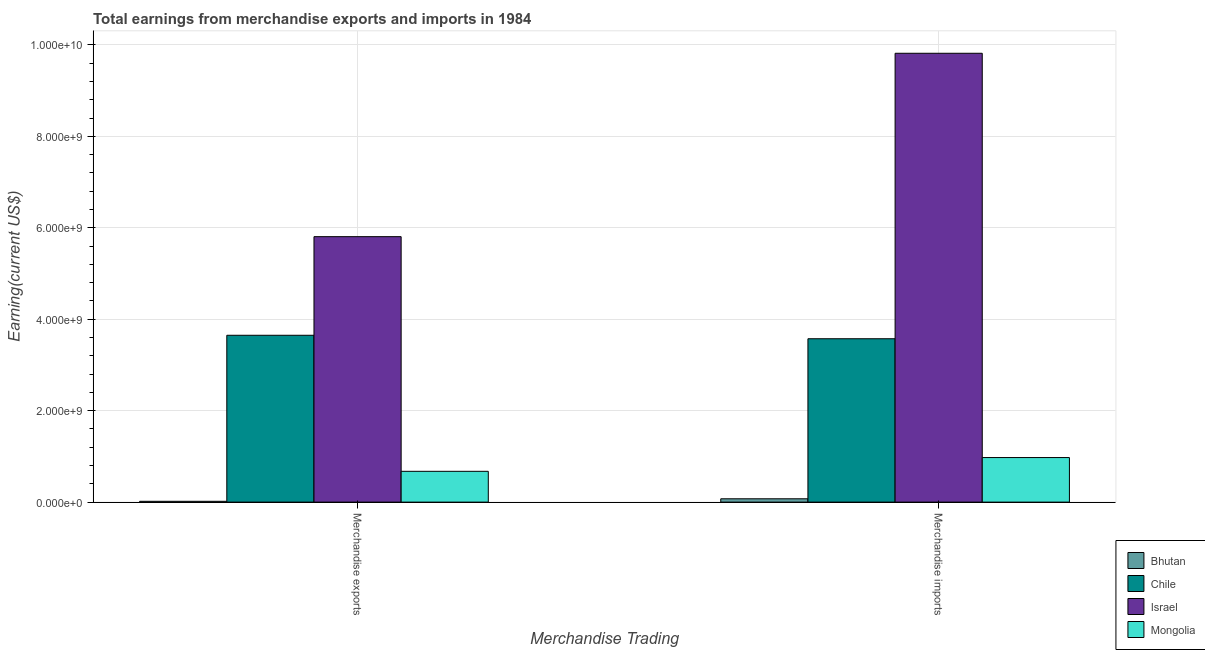How many groups of bars are there?
Offer a terse response. 2. Are the number of bars per tick equal to the number of legend labels?
Make the answer very short. Yes. Are the number of bars on each tick of the X-axis equal?
Offer a terse response. Yes. How many bars are there on the 2nd tick from the right?
Your answer should be compact. 4. What is the label of the 1st group of bars from the left?
Make the answer very short. Merchandise exports. What is the earnings from merchandise exports in Bhutan?
Provide a short and direct response. 1.80e+07. Across all countries, what is the maximum earnings from merchandise imports?
Your answer should be compact. 9.82e+09. Across all countries, what is the minimum earnings from merchandise exports?
Make the answer very short. 1.80e+07. In which country was the earnings from merchandise imports minimum?
Give a very brief answer. Bhutan. What is the total earnings from merchandise imports in the graph?
Give a very brief answer. 1.44e+1. What is the difference between the earnings from merchandise imports in Mongolia and that in Chile?
Provide a succinct answer. -2.60e+09. What is the difference between the earnings from merchandise imports in Chile and the earnings from merchandise exports in Israel?
Make the answer very short. -2.23e+09. What is the average earnings from merchandise imports per country?
Give a very brief answer. 3.61e+09. What is the difference between the earnings from merchandise imports and earnings from merchandise exports in Mongolia?
Ensure brevity in your answer.  3.01e+08. What is the ratio of the earnings from merchandise exports in Bhutan to that in Israel?
Your answer should be compact. 0. What does the 2nd bar from the left in Merchandise exports represents?
Offer a terse response. Chile. What does the 4th bar from the right in Merchandise exports represents?
Ensure brevity in your answer.  Bhutan. How many countries are there in the graph?
Provide a succinct answer. 4. What is the difference between two consecutive major ticks on the Y-axis?
Give a very brief answer. 2.00e+09. Does the graph contain any zero values?
Your answer should be very brief. No. Where does the legend appear in the graph?
Provide a short and direct response. Bottom right. What is the title of the graph?
Offer a very short reply. Total earnings from merchandise exports and imports in 1984. Does "Samoa" appear as one of the legend labels in the graph?
Ensure brevity in your answer.  No. What is the label or title of the X-axis?
Offer a very short reply. Merchandise Trading. What is the label or title of the Y-axis?
Provide a succinct answer. Earning(current US$). What is the Earning(current US$) in Bhutan in Merchandise exports?
Your answer should be compact. 1.80e+07. What is the Earning(current US$) of Chile in Merchandise exports?
Your answer should be compact. 3.65e+09. What is the Earning(current US$) in Israel in Merchandise exports?
Ensure brevity in your answer.  5.81e+09. What is the Earning(current US$) in Mongolia in Merchandise exports?
Provide a succinct answer. 6.74e+08. What is the Earning(current US$) of Bhutan in Merchandise imports?
Ensure brevity in your answer.  7.30e+07. What is the Earning(current US$) of Chile in Merchandise imports?
Make the answer very short. 3.57e+09. What is the Earning(current US$) in Israel in Merchandise imports?
Your answer should be compact. 9.82e+09. What is the Earning(current US$) in Mongolia in Merchandise imports?
Provide a short and direct response. 9.75e+08. Across all Merchandise Trading, what is the maximum Earning(current US$) of Bhutan?
Your response must be concise. 7.30e+07. Across all Merchandise Trading, what is the maximum Earning(current US$) of Chile?
Provide a succinct answer. 3.65e+09. Across all Merchandise Trading, what is the maximum Earning(current US$) of Israel?
Give a very brief answer. 9.82e+09. Across all Merchandise Trading, what is the maximum Earning(current US$) of Mongolia?
Ensure brevity in your answer.  9.75e+08. Across all Merchandise Trading, what is the minimum Earning(current US$) in Bhutan?
Ensure brevity in your answer.  1.80e+07. Across all Merchandise Trading, what is the minimum Earning(current US$) in Chile?
Offer a terse response. 3.57e+09. Across all Merchandise Trading, what is the minimum Earning(current US$) of Israel?
Provide a succinct answer. 5.81e+09. Across all Merchandise Trading, what is the minimum Earning(current US$) in Mongolia?
Ensure brevity in your answer.  6.74e+08. What is the total Earning(current US$) of Bhutan in the graph?
Offer a very short reply. 9.10e+07. What is the total Earning(current US$) of Chile in the graph?
Keep it short and to the point. 7.22e+09. What is the total Earning(current US$) of Israel in the graph?
Keep it short and to the point. 1.56e+1. What is the total Earning(current US$) of Mongolia in the graph?
Your response must be concise. 1.65e+09. What is the difference between the Earning(current US$) of Bhutan in Merchandise exports and that in Merchandise imports?
Make the answer very short. -5.50e+07. What is the difference between the Earning(current US$) in Chile in Merchandise exports and that in Merchandise imports?
Offer a terse response. 7.60e+07. What is the difference between the Earning(current US$) in Israel in Merchandise exports and that in Merchandise imports?
Offer a very short reply. -4.01e+09. What is the difference between the Earning(current US$) in Mongolia in Merchandise exports and that in Merchandise imports?
Your answer should be compact. -3.01e+08. What is the difference between the Earning(current US$) in Bhutan in Merchandise exports and the Earning(current US$) in Chile in Merchandise imports?
Your answer should be very brief. -3.56e+09. What is the difference between the Earning(current US$) in Bhutan in Merchandise exports and the Earning(current US$) in Israel in Merchandise imports?
Provide a short and direct response. -9.80e+09. What is the difference between the Earning(current US$) in Bhutan in Merchandise exports and the Earning(current US$) in Mongolia in Merchandise imports?
Provide a short and direct response. -9.57e+08. What is the difference between the Earning(current US$) of Chile in Merchandise exports and the Earning(current US$) of Israel in Merchandise imports?
Give a very brief answer. -6.17e+09. What is the difference between the Earning(current US$) of Chile in Merchandise exports and the Earning(current US$) of Mongolia in Merchandise imports?
Provide a short and direct response. 2.68e+09. What is the difference between the Earning(current US$) of Israel in Merchandise exports and the Earning(current US$) of Mongolia in Merchandise imports?
Give a very brief answer. 4.83e+09. What is the average Earning(current US$) of Bhutan per Merchandise Trading?
Provide a succinct answer. 4.55e+07. What is the average Earning(current US$) in Chile per Merchandise Trading?
Offer a terse response. 3.61e+09. What is the average Earning(current US$) in Israel per Merchandise Trading?
Your answer should be very brief. 7.81e+09. What is the average Earning(current US$) in Mongolia per Merchandise Trading?
Your answer should be very brief. 8.24e+08. What is the difference between the Earning(current US$) in Bhutan and Earning(current US$) in Chile in Merchandise exports?
Offer a very short reply. -3.63e+09. What is the difference between the Earning(current US$) of Bhutan and Earning(current US$) of Israel in Merchandise exports?
Provide a succinct answer. -5.79e+09. What is the difference between the Earning(current US$) in Bhutan and Earning(current US$) in Mongolia in Merchandise exports?
Your answer should be very brief. -6.56e+08. What is the difference between the Earning(current US$) in Chile and Earning(current US$) in Israel in Merchandise exports?
Your response must be concise. -2.16e+09. What is the difference between the Earning(current US$) in Chile and Earning(current US$) in Mongolia in Merchandise exports?
Offer a very short reply. 2.98e+09. What is the difference between the Earning(current US$) in Israel and Earning(current US$) in Mongolia in Merchandise exports?
Offer a very short reply. 5.13e+09. What is the difference between the Earning(current US$) in Bhutan and Earning(current US$) in Chile in Merchandise imports?
Provide a short and direct response. -3.50e+09. What is the difference between the Earning(current US$) in Bhutan and Earning(current US$) in Israel in Merchandise imports?
Keep it short and to the point. -9.75e+09. What is the difference between the Earning(current US$) of Bhutan and Earning(current US$) of Mongolia in Merchandise imports?
Your response must be concise. -9.02e+08. What is the difference between the Earning(current US$) in Chile and Earning(current US$) in Israel in Merchandise imports?
Your answer should be compact. -6.24e+09. What is the difference between the Earning(current US$) in Chile and Earning(current US$) in Mongolia in Merchandise imports?
Offer a very short reply. 2.60e+09. What is the difference between the Earning(current US$) in Israel and Earning(current US$) in Mongolia in Merchandise imports?
Your answer should be compact. 8.84e+09. What is the ratio of the Earning(current US$) in Bhutan in Merchandise exports to that in Merchandise imports?
Keep it short and to the point. 0.25. What is the ratio of the Earning(current US$) of Chile in Merchandise exports to that in Merchandise imports?
Give a very brief answer. 1.02. What is the ratio of the Earning(current US$) in Israel in Merchandise exports to that in Merchandise imports?
Your answer should be very brief. 0.59. What is the ratio of the Earning(current US$) in Mongolia in Merchandise exports to that in Merchandise imports?
Give a very brief answer. 0.69. What is the difference between the highest and the second highest Earning(current US$) of Bhutan?
Your answer should be very brief. 5.50e+07. What is the difference between the highest and the second highest Earning(current US$) in Chile?
Your response must be concise. 7.60e+07. What is the difference between the highest and the second highest Earning(current US$) of Israel?
Your answer should be compact. 4.01e+09. What is the difference between the highest and the second highest Earning(current US$) of Mongolia?
Provide a succinct answer. 3.01e+08. What is the difference between the highest and the lowest Earning(current US$) in Bhutan?
Provide a succinct answer. 5.50e+07. What is the difference between the highest and the lowest Earning(current US$) in Chile?
Provide a short and direct response. 7.60e+07. What is the difference between the highest and the lowest Earning(current US$) of Israel?
Make the answer very short. 4.01e+09. What is the difference between the highest and the lowest Earning(current US$) of Mongolia?
Offer a very short reply. 3.01e+08. 